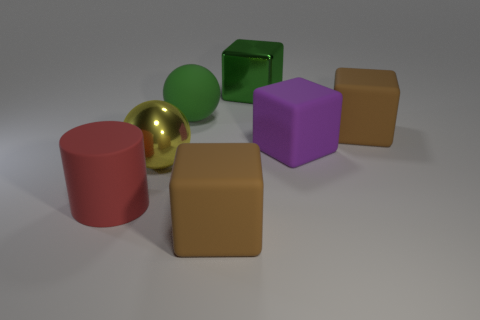Subtract all purple balls. How many brown blocks are left? 2 Subtract all large metal cubes. How many cubes are left? 3 Subtract 2 cubes. How many cubes are left? 2 Add 3 big green spheres. How many objects exist? 10 Subtract all purple cubes. How many cubes are left? 3 Subtract all blocks. How many objects are left? 3 Subtract all red blocks. Subtract all red balls. How many blocks are left? 4 Subtract all rubber cubes. Subtract all big metallic things. How many objects are left? 2 Add 5 green spheres. How many green spheres are left? 6 Add 5 green rubber things. How many green rubber things exist? 6 